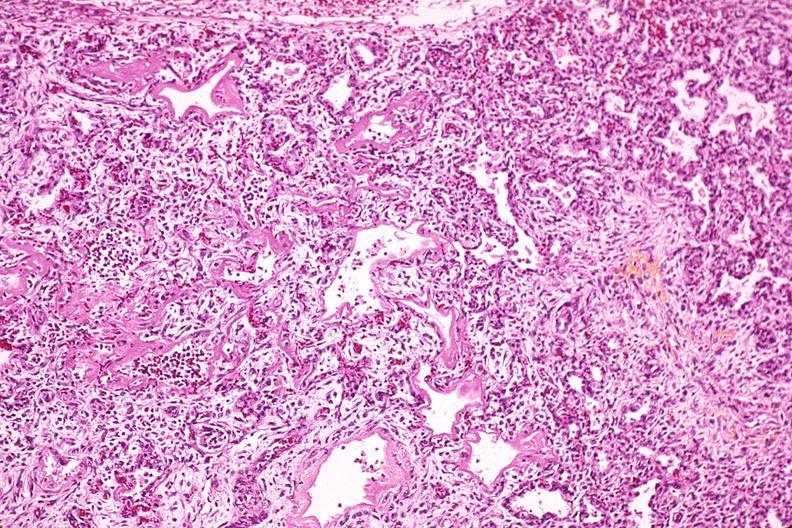where is this?
Answer the question using a single word or phrase. Lung 